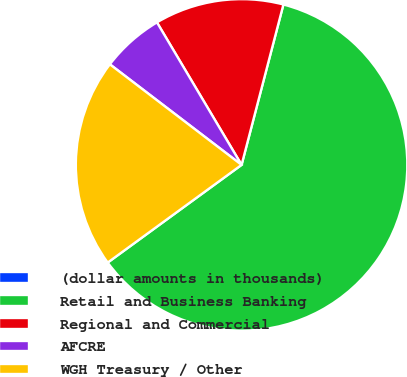<chart> <loc_0><loc_0><loc_500><loc_500><pie_chart><fcel>(dollar amounts in thousands)<fcel>Retail and Business Banking<fcel>Regional and Commercial<fcel>AFCRE<fcel>WGH Treasury / Other<nl><fcel>0.0%<fcel>60.9%<fcel>12.59%<fcel>6.09%<fcel>20.41%<nl></chart> 